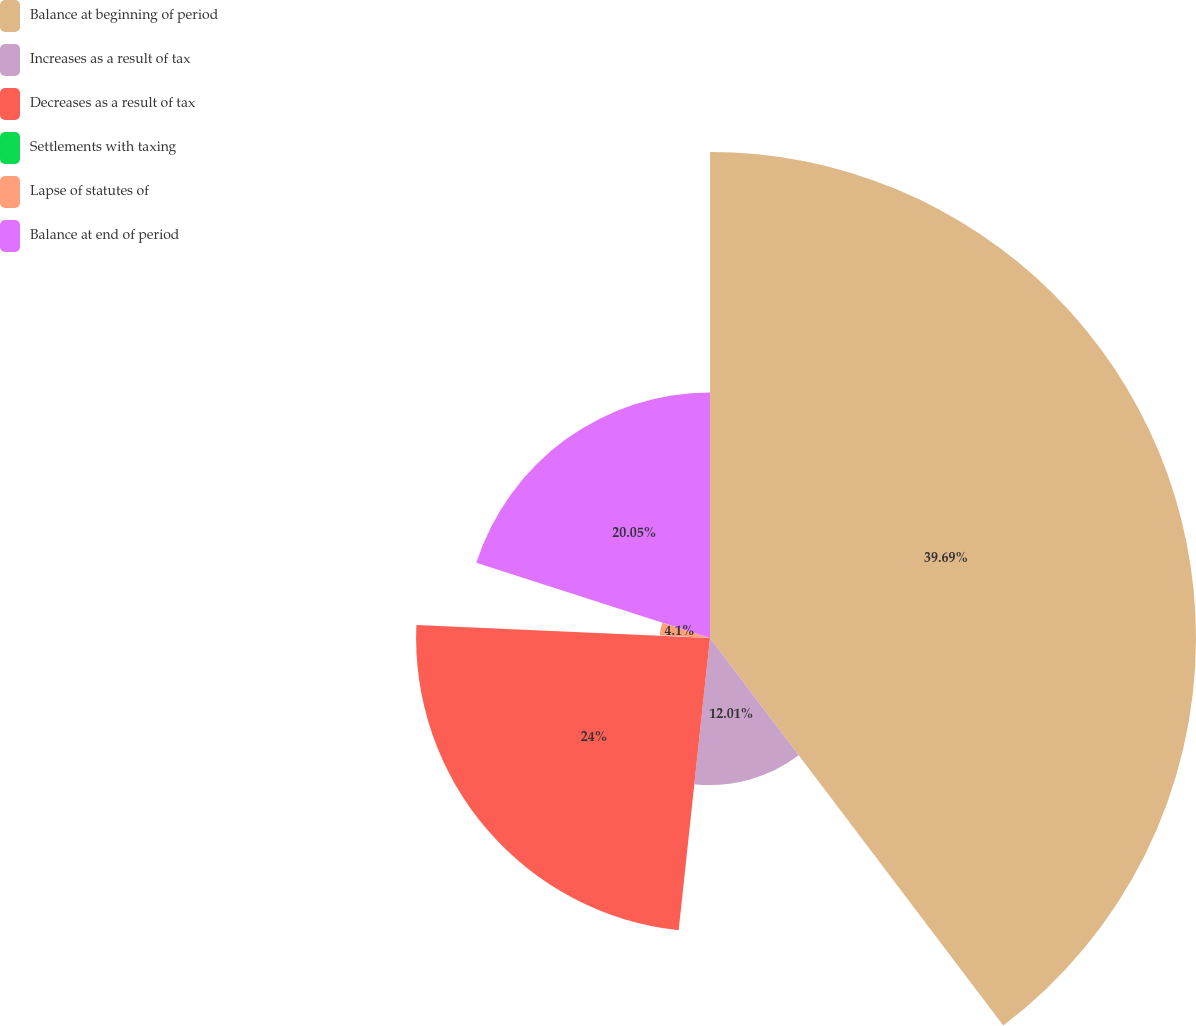Convert chart. <chart><loc_0><loc_0><loc_500><loc_500><pie_chart><fcel>Balance at beginning of period<fcel>Increases as a result of tax<fcel>Decreases as a result of tax<fcel>Settlements with taxing<fcel>Lapse of statutes of<fcel>Balance at end of period<nl><fcel>39.69%<fcel>12.01%<fcel>24.0%<fcel>0.15%<fcel>4.1%<fcel>20.05%<nl></chart> 